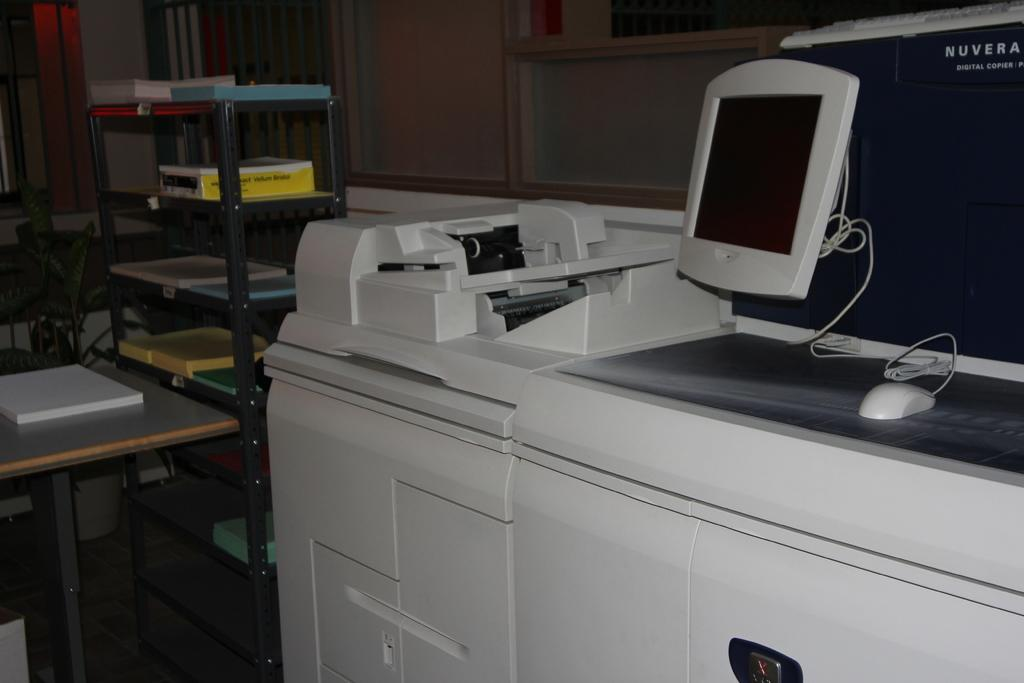Provide a one-sentence caption for the provided image. A Nuvera copy machine has a mouse and a monitor on it. 